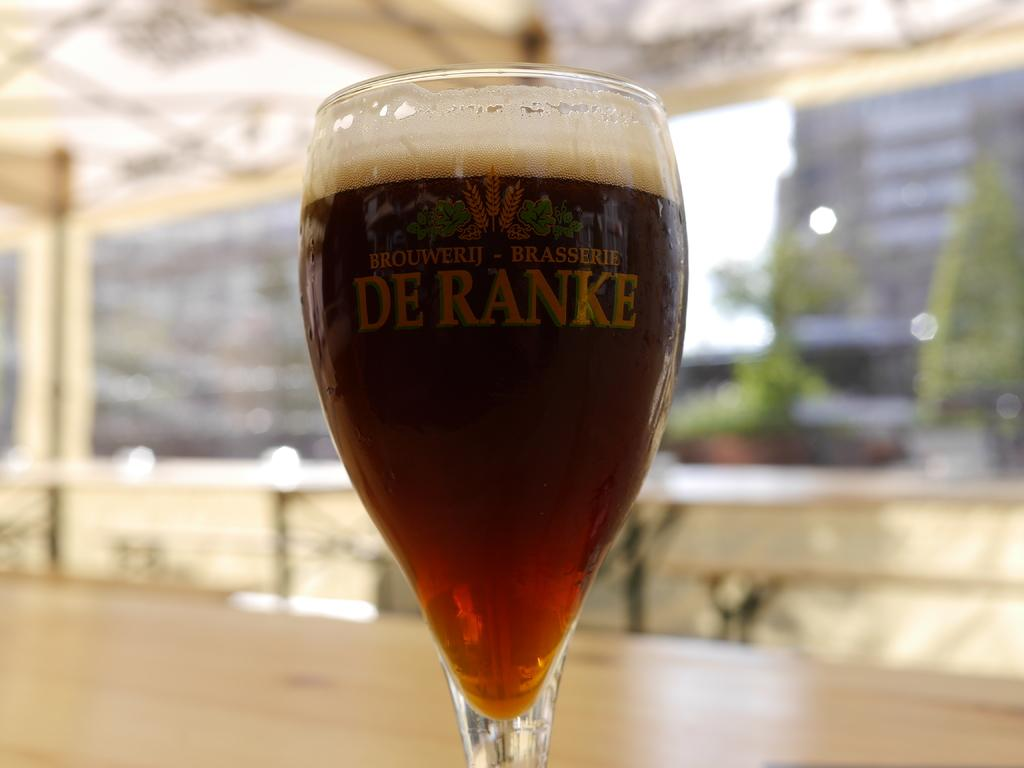<image>
Write a terse but informative summary of the picture. the word Deranke is on the bottle with beer 